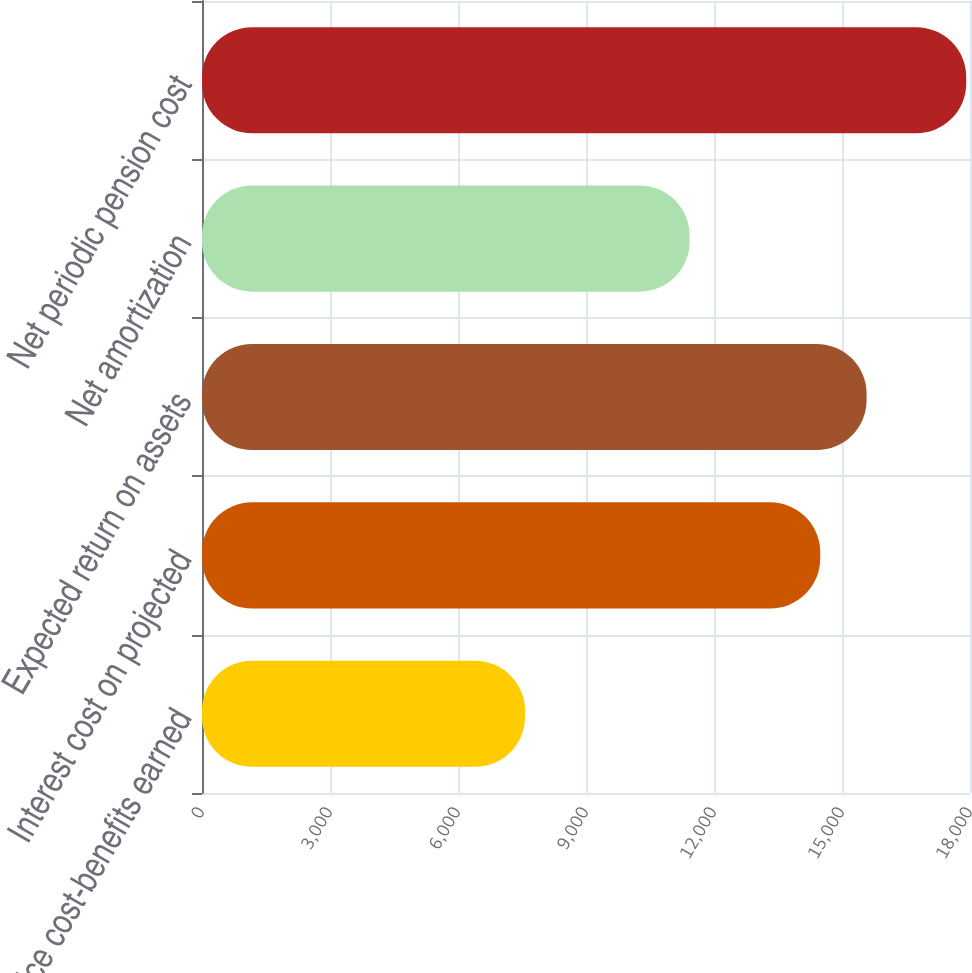<chart> <loc_0><loc_0><loc_500><loc_500><bar_chart><fcel>Service cost-benefits earned<fcel>Interest cost on projected<fcel>Expected return on assets<fcel>Net amortization<fcel>Net periodic pension cost<nl><fcel>7571<fcel>14490<fcel>15577<fcel>11428<fcel>17912<nl></chart> 